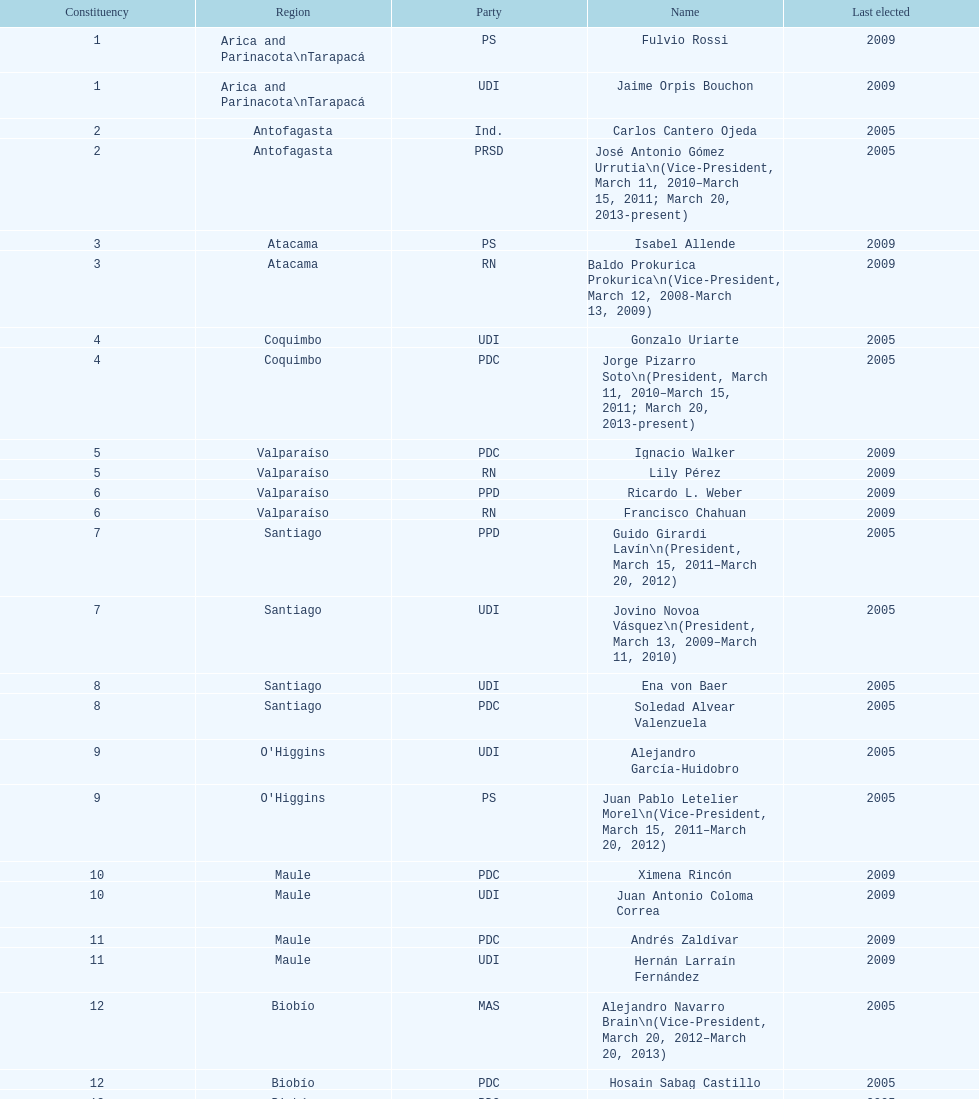What is the total number of constituencies? 19. 